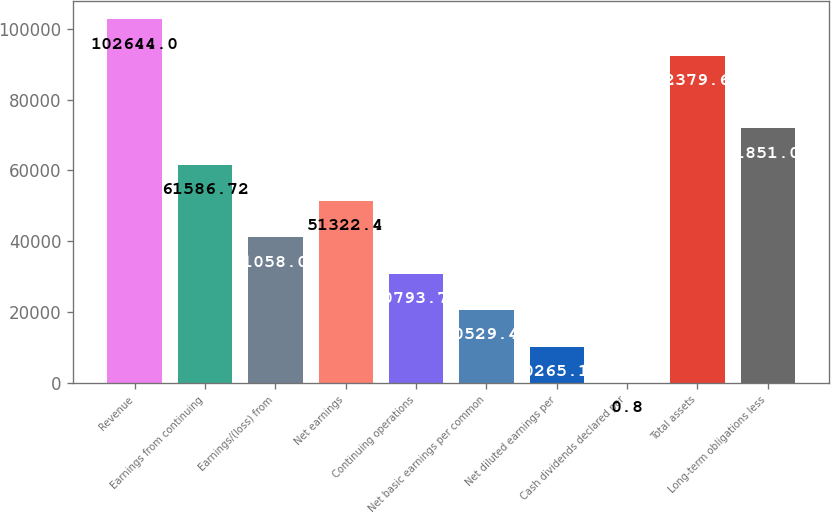Convert chart to OTSL. <chart><loc_0><loc_0><loc_500><loc_500><bar_chart><fcel>Revenue<fcel>Earnings from continuing<fcel>Earnings/(loss) from<fcel>Net earnings<fcel>Continuing operations<fcel>Net basic earnings per common<fcel>Net diluted earnings per<fcel>Cash dividends declared per<fcel>Total assets<fcel>Long-term obligations less<nl><fcel>102644<fcel>61586.7<fcel>41058.1<fcel>51322.4<fcel>30793.8<fcel>20529.4<fcel>10265.1<fcel>0.8<fcel>92379.7<fcel>71851<nl></chart> 